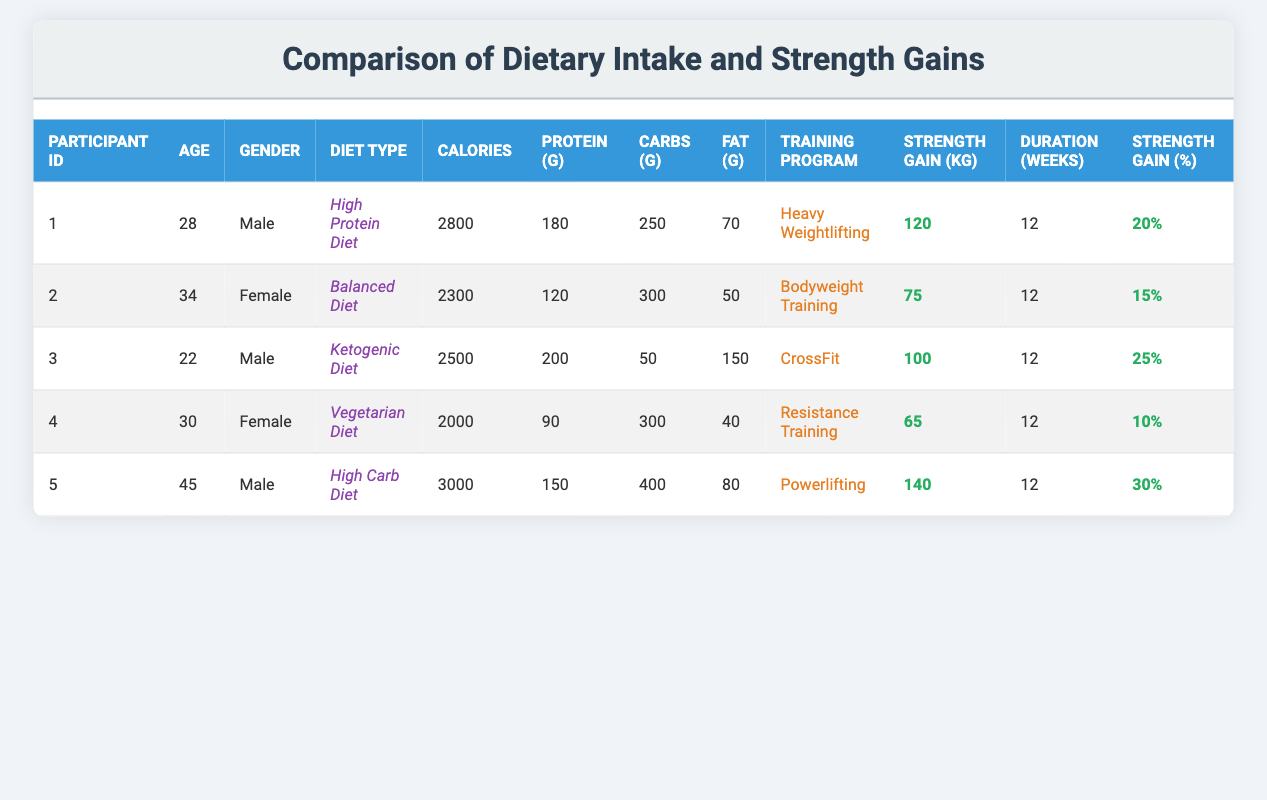What is the highest protein intake among the participants? Looking at the table, the highest protein intake is found in participant 3 with 200 grams, as this is the maximum value listed under the protein intake column.
Answer: 200 Which participant had the lowest strength gain percentage? By reviewing the strength gain percentage column, participant 4 has the lowest value at 10%, making it the minimum percentage among all participants.
Answer: 10% What is the average calories consumed by the participants? To calculate the average, sum the calories consumed by all participants: (2800 + 2300 + 2500 + 2000 + 3000) = 12600. There are 5 participants, so the average is 12600 / 5 = 2520.
Answer: 2520 Did any participant on a high protein diet gain weight greater than 20%? Participant 1, who is on a high protein diet, had a strength gain percentage of 20%, which means he did not exceed 20%. Therefore, the answer is no.
Answer: No What is the difference in strength gain (kg) between the participant with the highest strength gain and the one with the lowest? Participant 5 had the highest strength gain of 140 kg, while participant 4 had the lowest with 65 kg. The difference is calculated as 140 - 65 = 75 kg.
Answer: 75 Which gender had the highest average strength gain percentage? Calculate the average for each gender: Male averages (20 + 25 + 30) / 3 = 25%; Female averages (15 + 10) / 2 = 12.5%. Males have the highest average strength gain percentage.
Answer: Male How many participants followed a vegetarian diet? By inspecting the diet type column, only participant 4 is listed as following a vegetarian diet, indicating that there is just one participant in this category.
Answer: 1 What is the total fat intake in grams for all participants combined? Adding up the fat intake values gives: (70 + 50 + 150 + 40 + 80) = 390 grams. This total represents the combined fat intake.
Answer: 390 